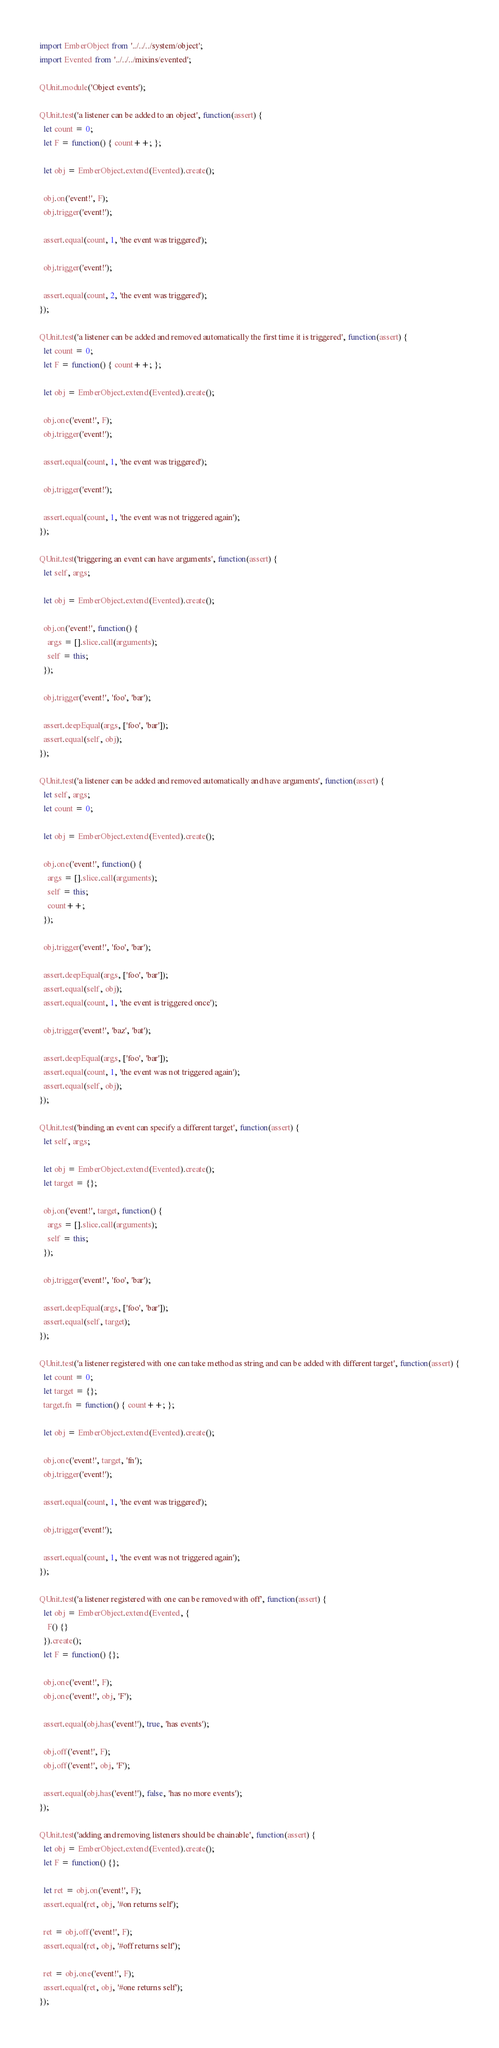Convert code to text. <code><loc_0><loc_0><loc_500><loc_500><_JavaScript_>import EmberObject from '../../../system/object';
import Evented from '../../../mixins/evented';

QUnit.module('Object events');

QUnit.test('a listener can be added to an object', function(assert) {
  let count = 0;
  let F = function() { count++; };

  let obj = EmberObject.extend(Evented).create();

  obj.on('event!', F);
  obj.trigger('event!');

  assert.equal(count, 1, 'the event was triggered');

  obj.trigger('event!');

  assert.equal(count, 2, 'the event was triggered');
});

QUnit.test('a listener can be added and removed automatically the first time it is triggered', function(assert) {
  let count = 0;
  let F = function() { count++; };

  let obj = EmberObject.extend(Evented).create();

  obj.one('event!', F);
  obj.trigger('event!');

  assert.equal(count, 1, 'the event was triggered');

  obj.trigger('event!');

  assert.equal(count, 1, 'the event was not triggered again');
});

QUnit.test('triggering an event can have arguments', function(assert) {
  let self, args;

  let obj = EmberObject.extend(Evented).create();

  obj.on('event!', function() {
    args = [].slice.call(arguments);
    self = this;
  });

  obj.trigger('event!', 'foo', 'bar');

  assert.deepEqual(args, ['foo', 'bar']);
  assert.equal(self, obj);
});

QUnit.test('a listener can be added and removed automatically and have arguments', function(assert) {
  let self, args;
  let count = 0;

  let obj = EmberObject.extend(Evented).create();

  obj.one('event!', function() {
    args = [].slice.call(arguments);
    self = this;
    count++;
  });

  obj.trigger('event!', 'foo', 'bar');

  assert.deepEqual(args, ['foo', 'bar']);
  assert.equal(self, obj);
  assert.equal(count, 1, 'the event is triggered once');

  obj.trigger('event!', 'baz', 'bat');

  assert.deepEqual(args, ['foo', 'bar']);
  assert.equal(count, 1, 'the event was not triggered again');
  assert.equal(self, obj);
});

QUnit.test('binding an event can specify a different target', function(assert) {
  let self, args;

  let obj = EmberObject.extend(Evented).create();
  let target = {};

  obj.on('event!', target, function() {
    args = [].slice.call(arguments);
    self = this;
  });

  obj.trigger('event!', 'foo', 'bar');

  assert.deepEqual(args, ['foo', 'bar']);
  assert.equal(self, target);
});

QUnit.test('a listener registered with one can take method as string and can be added with different target', function(assert) {
  let count = 0;
  let target = {};
  target.fn = function() { count++; };

  let obj = EmberObject.extend(Evented).create();

  obj.one('event!', target, 'fn');
  obj.trigger('event!');

  assert.equal(count, 1, 'the event was triggered');

  obj.trigger('event!');

  assert.equal(count, 1, 'the event was not triggered again');
});

QUnit.test('a listener registered with one can be removed with off', function(assert) {
  let obj = EmberObject.extend(Evented, {
    F() {}
  }).create();
  let F = function() {};

  obj.one('event!', F);
  obj.one('event!', obj, 'F');

  assert.equal(obj.has('event!'), true, 'has events');

  obj.off('event!', F);
  obj.off('event!', obj, 'F');

  assert.equal(obj.has('event!'), false, 'has no more events');
});

QUnit.test('adding and removing listeners should be chainable', function(assert) {
  let obj = EmberObject.extend(Evented).create();
  let F = function() {};

  let ret = obj.on('event!', F);
  assert.equal(ret, obj, '#on returns self');

  ret = obj.off('event!', F);
  assert.equal(ret, obj, '#off returns self');

  ret = obj.one('event!', F);
  assert.equal(ret, obj, '#one returns self');
});
</code> 